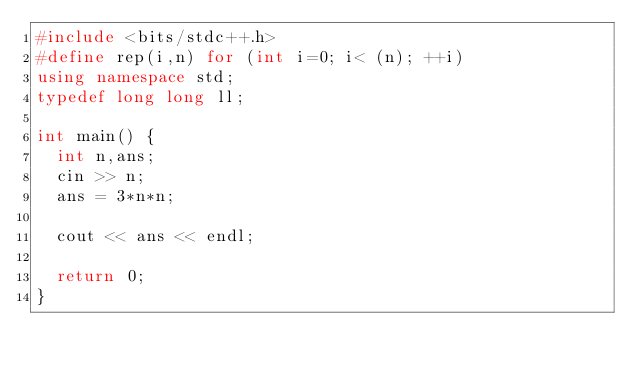<code> <loc_0><loc_0><loc_500><loc_500><_C++_>#include <bits/stdc++.h>
#define rep(i,n) for (int i=0; i< (n); ++i)
using namespace std;
typedef long long ll;

int main() {
  int n,ans;
  cin >> n;
  ans = 3*n*n;

  cout << ans << endl;
  
  return 0;
}
</code> 